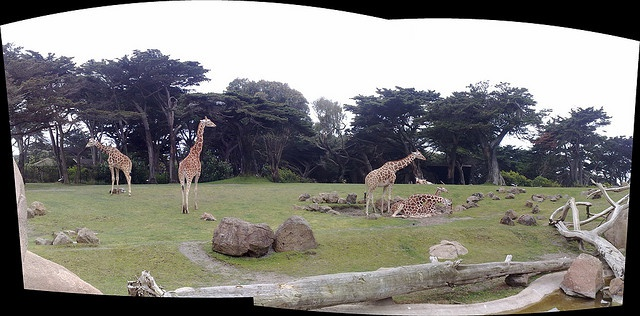Describe the objects in this image and their specific colors. I can see giraffe in black, darkgray, and gray tones, giraffe in black, darkgray, and gray tones, giraffe in black, darkgray, and gray tones, giraffe in black, darkgray, gray, and tan tones, and giraffe in black, darkgray, and gray tones in this image. 